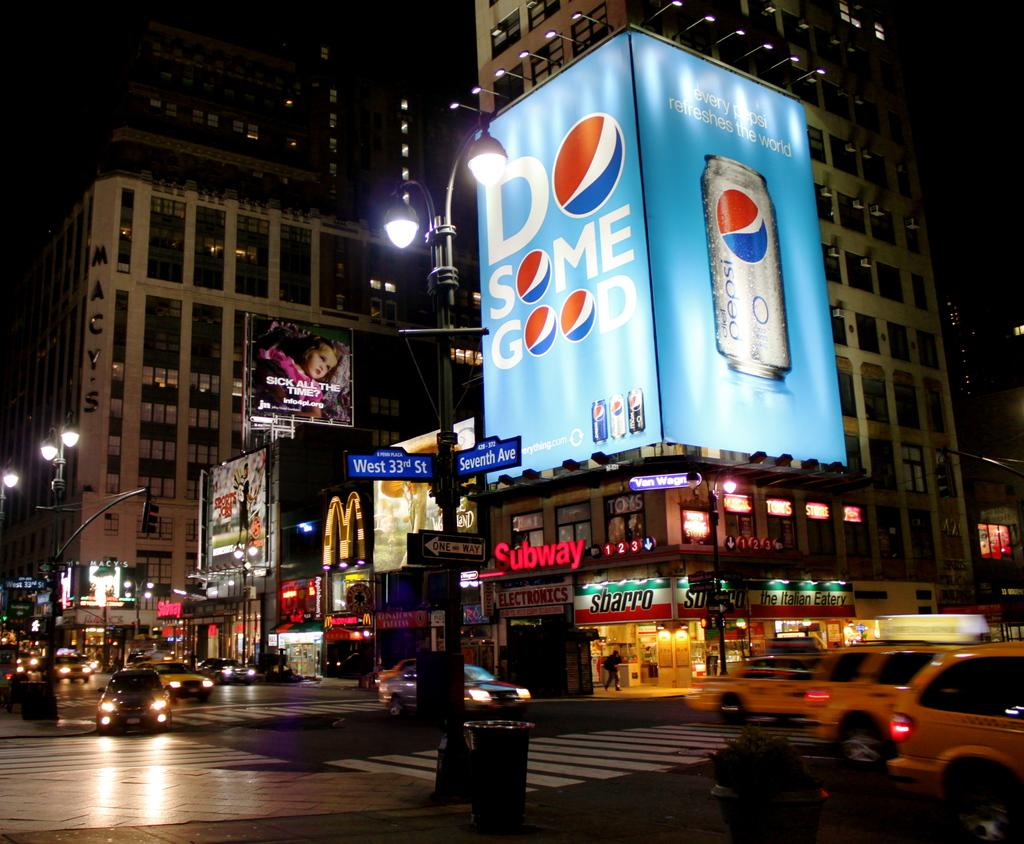<image>
Give a short and clear explanation of the subsequent image. Pepsi commercial is shown on the monitors on a street corner as cabs drive by. 